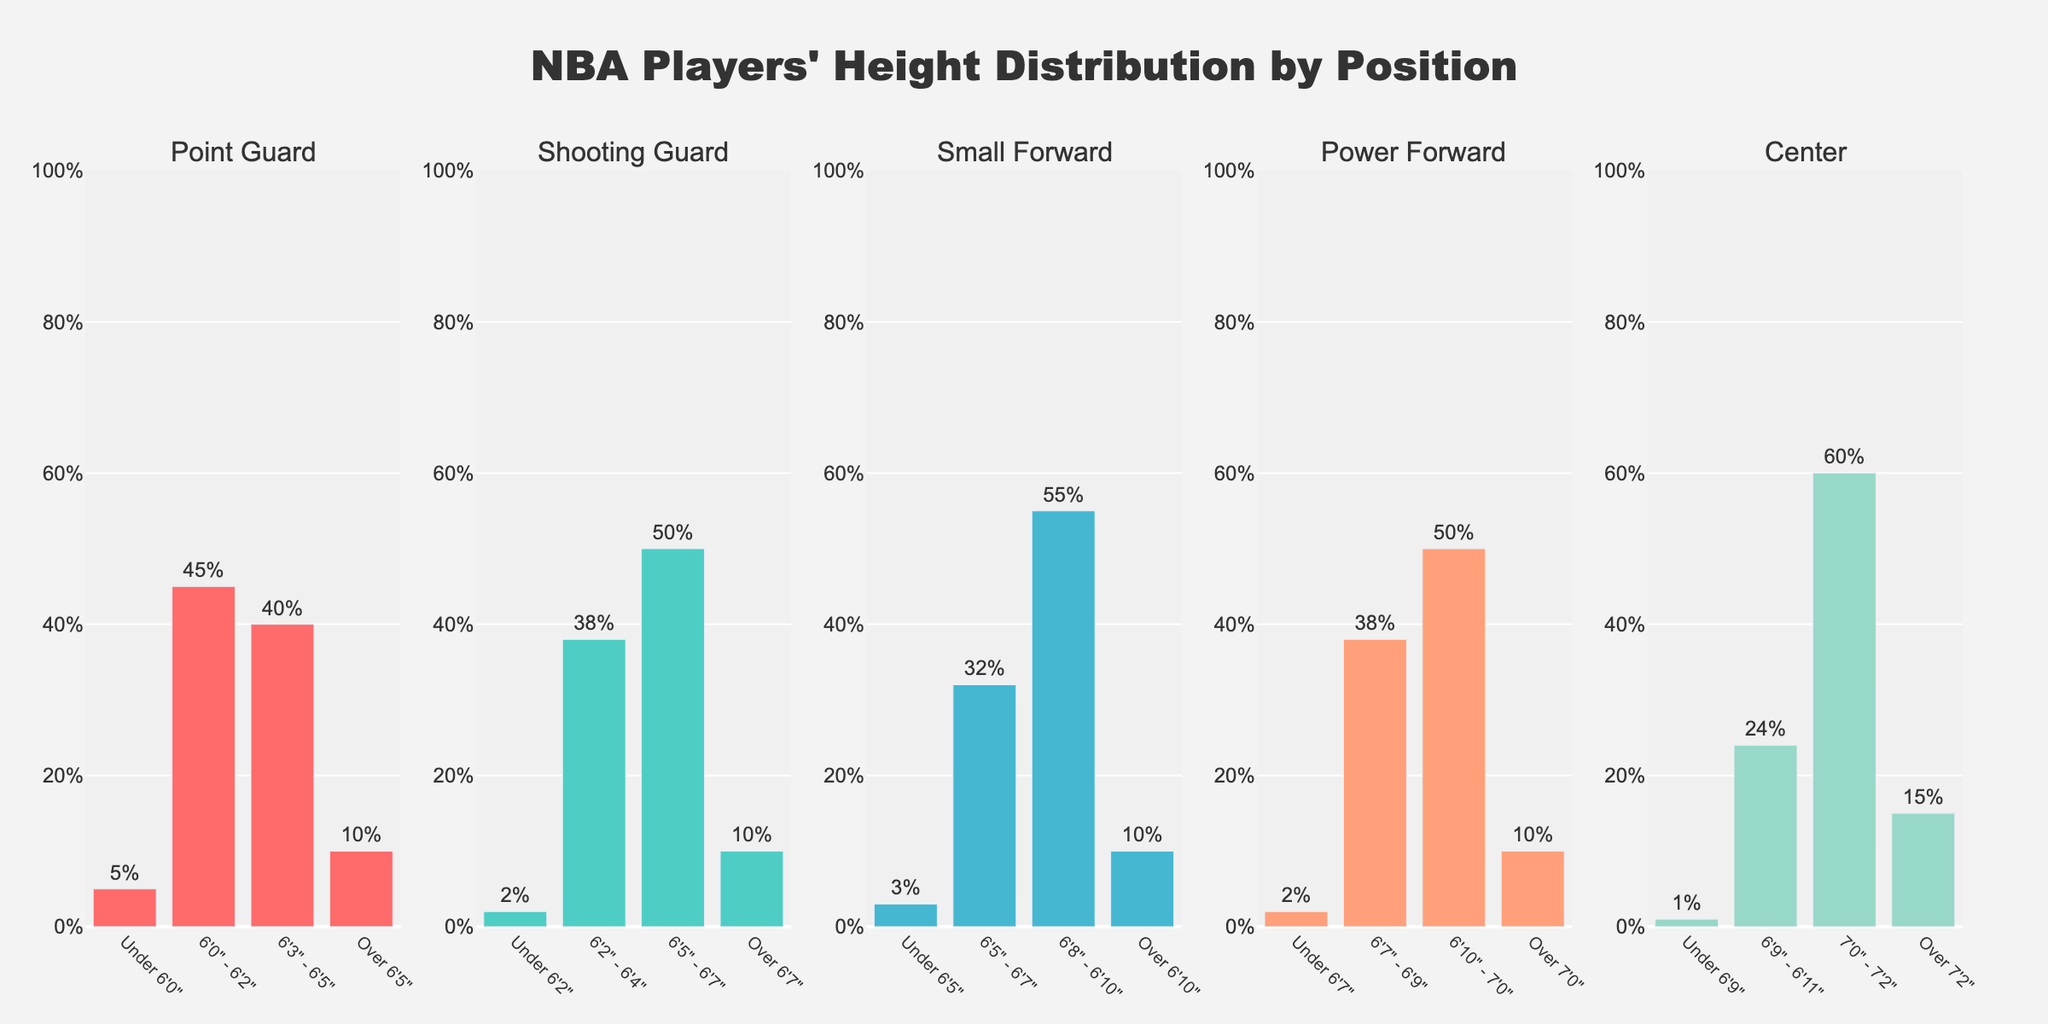How many height ranges are there for each position? Count the number of bars (heights) for each position in the figure. Each position has four height ranges indicated by the bars.
Answer: 4 What's the percentage of Point Guards who are between 6'0" and 6'2"? Look at the Point Guard section and find the bar labeled "6'0" - 6'2". The percentage is displayed just above/within the bar.
Answer: 45% Which position has the highest percentage of players over 7'2"? Compare the heights of the bars labeled "Over 7'2" for all positions. The bar for Centers has the highest percentage.
Answer: Center What is the total percentage of Small Forwards who are 6'8" or taller? Add the percentages for the height ranges "6'8" - 6'10"" and "Over 6'10"" within the Small Forward section. The percentages are 55% and 10% respectively. So, 55% + 10% = 65%.
Answer: 65% For which height range do Power Forwards have the lowest percentage? Inspect the heights of the bars within the Power Forward section. The bar labeled "Under 6'7"" is the shortest, representing the lowest percentage.
Answer: Under 6'7" Compare the highest bars for Point Guards and Shooting Guards. Which one has a higher percentage and how much higher is it? Identify the tallest bars for Point Guards (6'0" - 6'2", 45%) and Shooting Guards (6'5" - 6'7", 50%). The highest bar for Shooting Guards is 50%, which is 5% higher than the highest bar for Point Guards.
Answer: Shooting Guards; 5% higher What is the combined percentage of Centers who are 7'0" or taller? Add the percentages for "7'0" - 7'2"" and "Over 7'2"" within the Center section. The percentages are 60% and 15% respectively, so 60% + 15% = 75%.
Answer: 75% Which position has the least percentage of players under their smallest height range? Compare the smallest height range bars across all positions. Centers have the lowest percentage in their smallest height range ("Under 6'9"") at 1%.
Answer: Center What percentage of Power Forwards are between 6'7" and 6'9"? Look at the percentage on the bar labeled "6'7" - 6'9"" in the Power Forward section.
Answer: 38% Is the percentage of Shooting Guards over 6'7" higher or lower than the percentage of Small Forwards over 6'10"? Compare the "Over 6'7"" bar for Shooting Guards (10%) and the "Over 6'10"" bar for Small Forwards (10%). Both percentages are equal.
Answer: Equal 